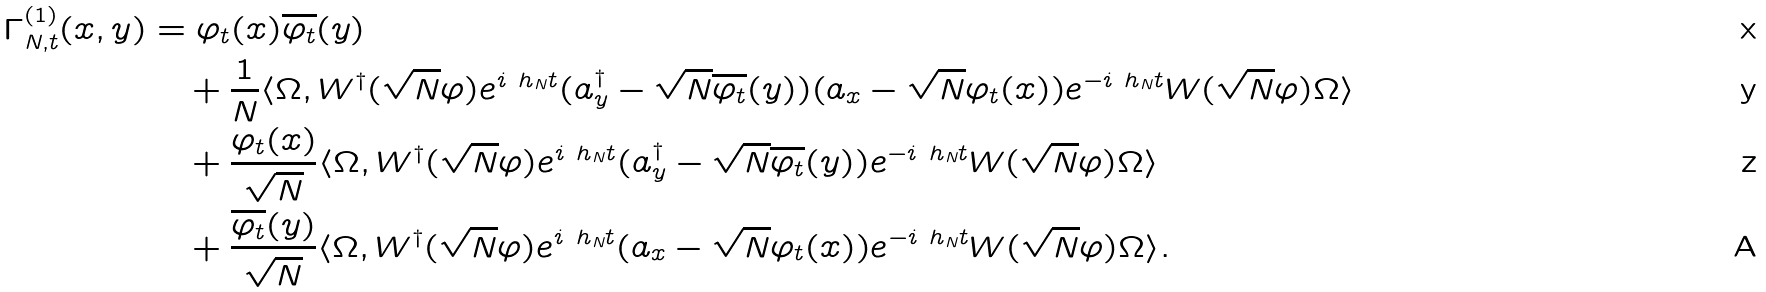<formula> <loc_0><loc_0><loc_500><loc_500>\Gamma _ { N , t } ^ { ( 1 ) } ( x , y ) & = \varphi _ { t } ( x ) \overline { \varphi _ { t } } ( y ) \\ & \quad + \frac { 1 } { N } \langle \Omega , W ^ { \dag } ( \sqrt { N } \varphi ) e ^ { i \ h _ { N } t } ( a _ { y } ^ { \dag } - \sqrt { N } \overline { \varphi _ { t } } ( y ) ) ( a _ { x } - \sqrt { N } \varphi _ { t } ( x ) ) e ^ { - i \ h _ { N } t } W ( \sqrt { N } \varphi ) \Omega \rangle \\ & \quad + \frac { \varphi _ { t } ( x ) } { \sqrt { N } } \langle \Omega , W ^ { \dag } ( \sqrt { N } \varphi ) e ^ { i \ h _ { N } t } ( a _ { y } ^ { \dag } - \sqrt { N } \overline { \varphi _ { t } } ( y ) ) e ^ { - i \ h _ { N } t } W ( \sqrt { N } \varphi ) \Omega \rangle \\ & \quad + \frac { \overline { \varphi _ { t } } ( y ) } { \sqrt { N } } \langle \Omega , W ^ { \dag } ( \sqrt { N } \varphi ) e ^ { i \ h _ { N } t } ( a _ { x } - \sqrt { N } \varphi _ { t } ( x ) ) e ^ { - i \ h _ { N } t } W ( \sqrt { N } \varphi ) \Omega \rangle .</formula> 